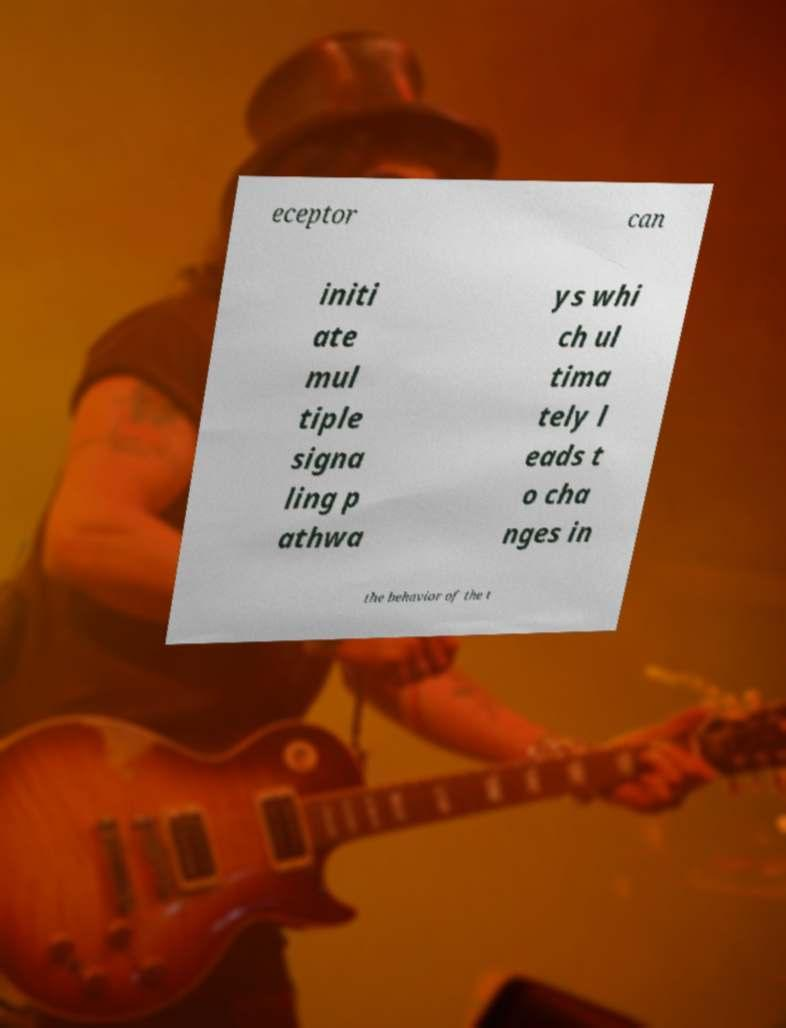There's text embedded in this image that I need extracted. Can you transcribe it verbatim? eceptor can initi ate mul tiple signa ling p athwa ys whi ch ul tima tely l eads t o cha nges in the behavior of the t 